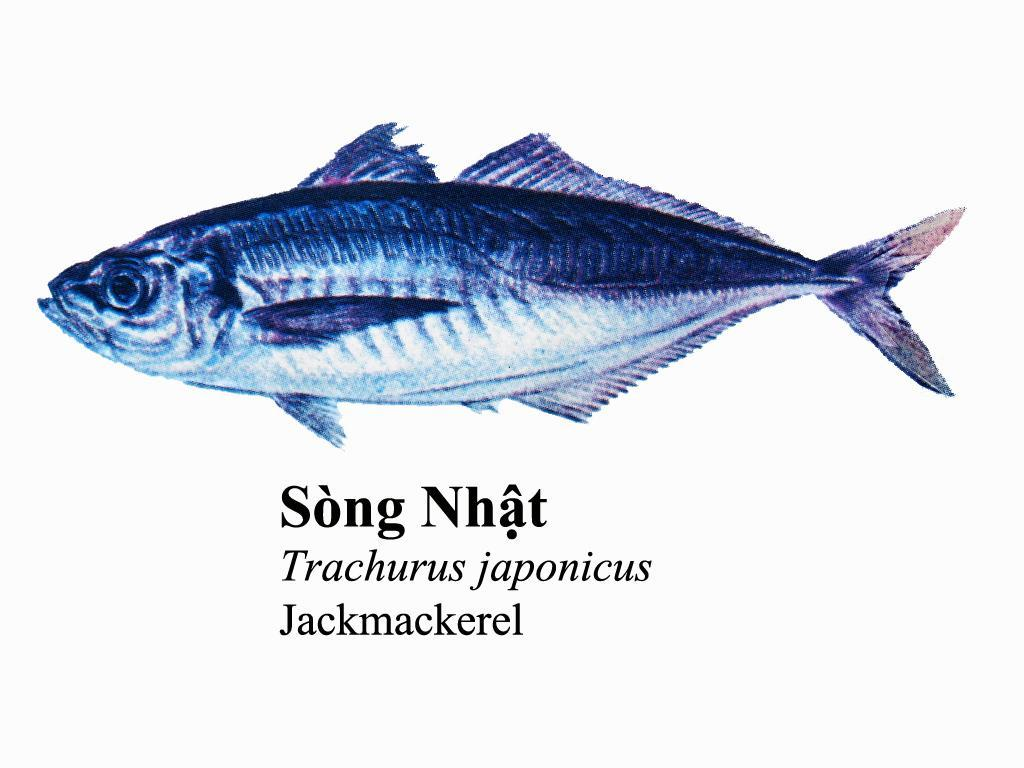What is the main subject of the image? There is a fish in the center of the image. What color is the fish? The fish is in a blue color. What can be found at the bottom of the image? There is some text at the bottom of the image. What color is the background of the image? The background of the image is white. What type of hammer is being used to fix the unit in the image? There is no hammer or unit present in the image; it features a fish in a blue color with a white background and some text at the bottom. 